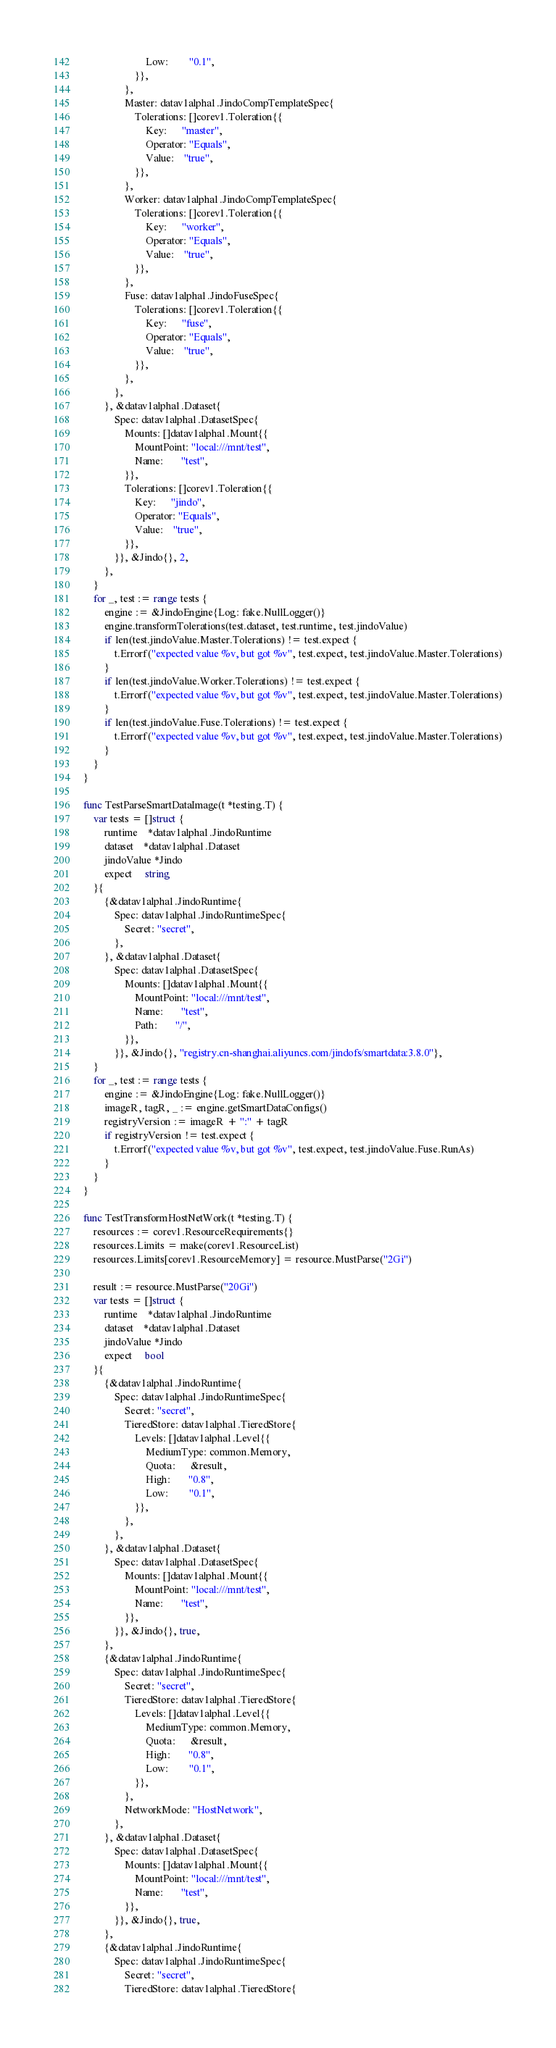<code> <loc_0><loc_0><loc_500><loc_500><_Go_>						Low:        "0.1",
					}},
				},
				Master: datav1alpha1.JindoCompTemplateSpec{
					Tolerations: []corev1.Toleration{{
						Key:      "master",
						Operator: "Equals",
						Value:    "true",
					}},
				},
				Worker: datav1alpha1.JindoCompTemplateSpec{
					Tolerations: []corev1.Toleration{{
						Key:      "worker",
						Operator: "Equals",
						Value:    "true",
					}},
				},
				Fuse: datav1alpha1.JindoFuseSpec{
					Tolerations: []corev1.Toleration{{
						Key:      "fuse",
						Operator: "Equals",
						Value:    "true",
					}},
				},
			},
		}, &datav1alpha1.Dataset{
			Spec: datav1alpha1.DatasetSpec{
				Mounts: []datav1alpha1.Mount{{
					MountPoint: "local:///mnt/test",
					Name:       "test",
				}},
				Tolerations: []corev1.Toleration{{
					Key:      "jindo",
					Operator: "Equals",
					Value:    "true",
				}},
			}}, &Jindo{}, 2,
		},
	}
	for _, test := range tests {
		engine := &JindoEngine{Log: fake.NullLogger()}
		engine.transformTolerations(test.dataset, test.runtime, test.jindoValue)
		if len(test.jindoValue.Master.Tolerations) != test.expect {
			t.Errorf("expected value %v, but got %v", test.expect, test.jindoValue.Master.Tolerations)
		}
		if len(test.jindoValue.Worker.Tolerations) != test.expect {
			t.Errorf("expected value %v, but got %v", test.expect, test.jindoValue.Master.Tolerations)
		}
		if len(test.jindoValue.Fuse.Tolerations) != test.expect {
			t.Errorf("expected value %v, but got %v", test.expect, test.jindoValue.Master.Tolerations)
		}
	}
}

func TestParseSmartDataImage(t *testing.T) {
	var tests = []struct {
		runtime    *datav1alpha1.JindoRuntime
		dataset    *datav1alpha1.Dataset
		jindoValue *Jindo
		expect     string
	}{
		{&datav1alpha1.JindoRuntime{
			Spec: datav1alpha1.JindoRuntimeSpec{
				Secret: "secret",
			},
		}, &datav1alpha1.Dataset{
			Spec: datav1alpha1.DatasetSpec{
				Mounts: []datav1alpha1.Mount{{
					MountPoint: "local:///mnt/test",
					Name:       "test",
					Path:       "/",
				}},
			}}, &Jindo{}, "registry.cn-shanghai.aliyuncs.com/jindofs/smartdata:3.8.0"},
	}
	for _, test := range tests {
		engine := &JindoEngine{Log: fake.NullLogger()}
		imageR, tagR, _ := engine.getSmartDataConfigs()
		registryVersion := imageR + ":" + tagR
		if registryVersion != test.expect {
			t.Errorf("expected value %v, but got %v", test.expect, test.jindoValue.Fuse.RunAs)
		}
	}
}

func TestTransformHostNetWork(t *testing.T) {
	resources := corev1.ResourceRequirements{}
	resources.Limits = make(corev1.ResourceList)
	resources.Limits[corev1.ResourceMemory] = resource.MustParse("2Gi")

	result := resource.MustParse("20Gi")
	var tests = []struct {
		runtime    *datav1alpha1.JindoRuntime
		dataset    *datav1alpha1.Dataset
		jindoValue *Jindo
		expect     bool
	}{
		{&datav1alpha1.JindoRuntime{
			Spec: datav1alpha1.JindoRuntimeSpec{
				Secret: "secret",
				TieredStore: datav1alpha1.TieredStore{
					Levels: []datav1alpha1.Level{{
						MediumType: common.Memory,
						Quota:      &result,
						High:       "0.8",
						Low:        "0.1",
					}},
				},
			},
		}, &datav1alpha1.Dataset{
			Spec: datav1alpha1.DatasetSpec{
				Mounts: []datav1alpha1.Mount{{
					MountPoint: "local:///mnt/test",
					Name:       "test",
				}},
			}}, &Jindo{}, true,
		},
		{&datav1alpha1.JindoRuntime{
			Spec: datav1alpha1.JindoRuntimeSpec{
				Secret: "secret",
				TieredStore: datav1alpha1.TieredStore{
					Levels: []datav1alpha1.Level{{
						MediumType: common.Memory,
						Quota:      &result,
						High:       "0.8",
						Low:        "0.1",
					}},
				},
				NetworkMode: "HostNetwork",
			},
		}, &datav1alpha1.Dataset{
			Spec: datav1alpha1.DatasetSpec{
				Mounts: []datav1alpha1.Mount{{
					MountPoint: "local:///mnt/test",
					Name:       "test",
				}},
			}}, &Jindo{}, true,
		},
		{&datav1alpha1.JindoRuntime{
			Spec: datav1alpha1.JindoRuntimeSpec{
				Secret: "secret",
				TieredStore: datav1alpha1.TieredStore{</code> 